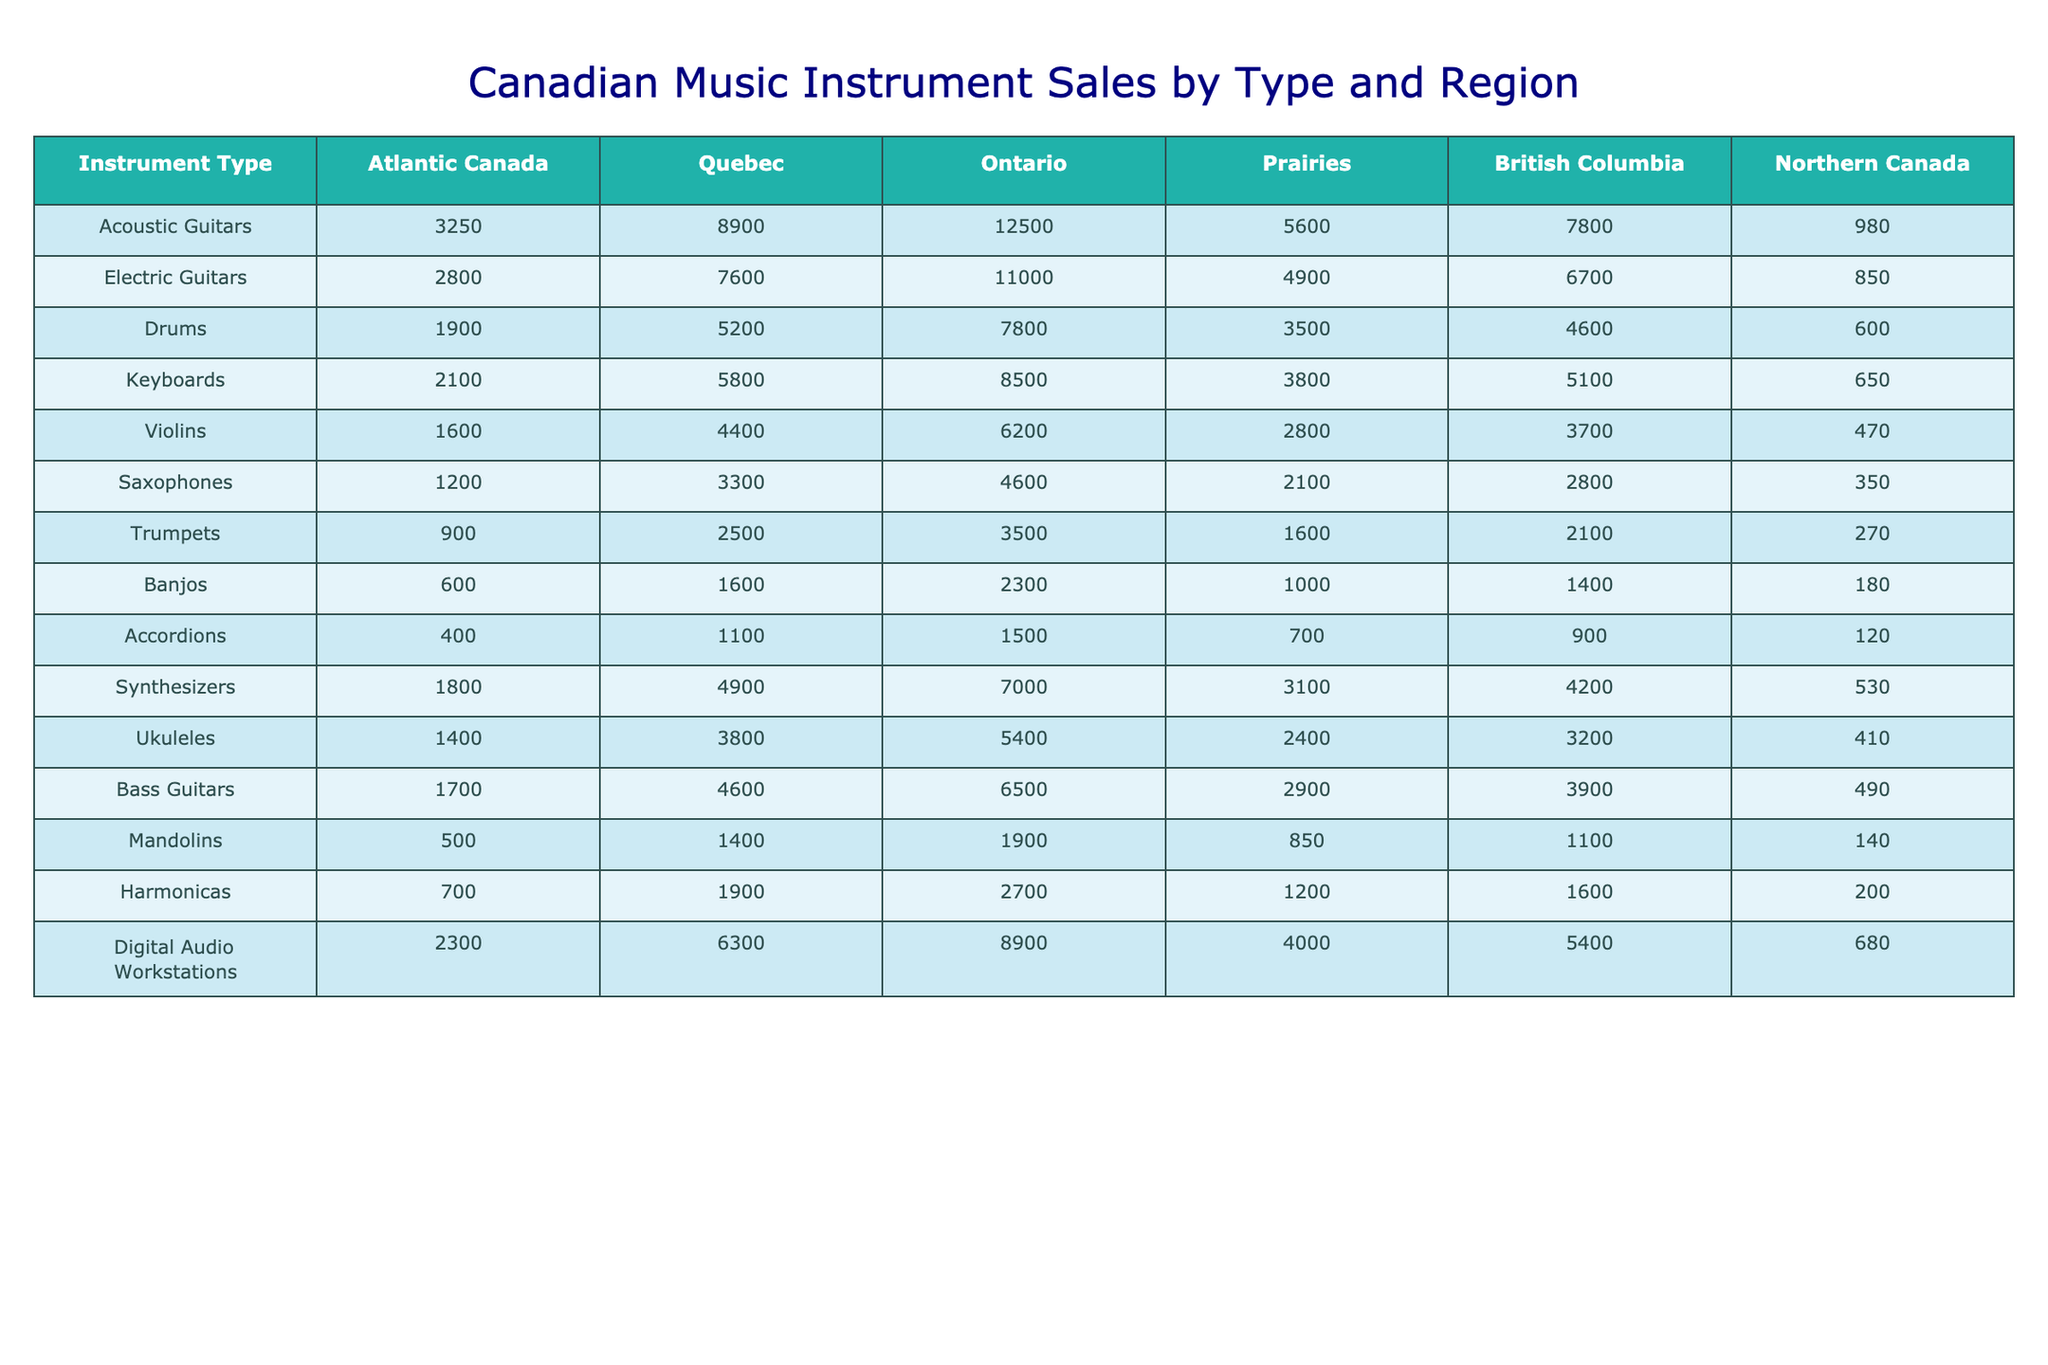What is the total number of acoustic guitars sold across all regions? To find the total, add the quantities of acoustic guitars from each region: 3250 + 8900 + 12500 + 5600 + 7800 + 980 = 32530
Answer: 32530 Which region sold the most electric guitars? Looking at the electric guitar sales, Ontario has the highest number at 11000.
Answer: Ontario What is the sales difference between drums in Atlantic Canada and Northern Canada? The sales in Atlantic Canada are 1900 and in Northern Canada are 600. The difference is 1900 - 600 = 1300.
Answer: 1300 What is the average sales for keyboards sold in the Prairies and British Columbia? Adding the sales for keyboards in the Prairies (3800) and British Columbia (5100), gives 3800 + 5100 = 8900. To find the average, divide by 2: 8900 / 2 = 4450.
Answer: 4450 Which instrument type had the lowest sales in Northern Canada? Looking at the instruments listed for Northern Canada, the lowest sales value is for accordions at 120.
Answer: Accordions Do more drums than saxophones sell in Quebec? In Quebec, drums sold 5200 and saxophones sold 3300. Since 5200 is greater than 3300, the answer is true.
Answer: Yes What is the total sales for digital audio workstations and synthesizers across all regions? For digital audio workstations, the total is: 2300 + 6300 + 8900 + 4000 + 5400 + 680 = 18680. For synthesizers, it’s 1800 + 4900 + 7000 + 3100 + 4200 + 530 = 21830. Adding these totals: 18680 + 21830 = 40510.
Answer: 40510 Which region sold the least number of trumpets? The trumpet sales in the regions are: Atlantic Canada (900), Quebec (2500), Ontario (3500), Prairies (1600), British Columbia (2100), and Northern Canada (270). The least sales are in Atlantic Canada at 900.
Answer: Atlantic Canada If you combine the number of ukuleles and violins sold in British Columbia, what is the total? Ukuleles sold in British Columbia totaled 3200, and violins totaled 3700. Adding these two gives 3200 + 3700 = 6900.
Answer: 6900 How many more electric guitars were sold in Ontario compared to Atlantic Canada? Electric guitars sold in Ontario are 11000, and in Atlantic Canada, they are 2800. The difference is 11000 - 2800 = 8200.
Answer: 8200 